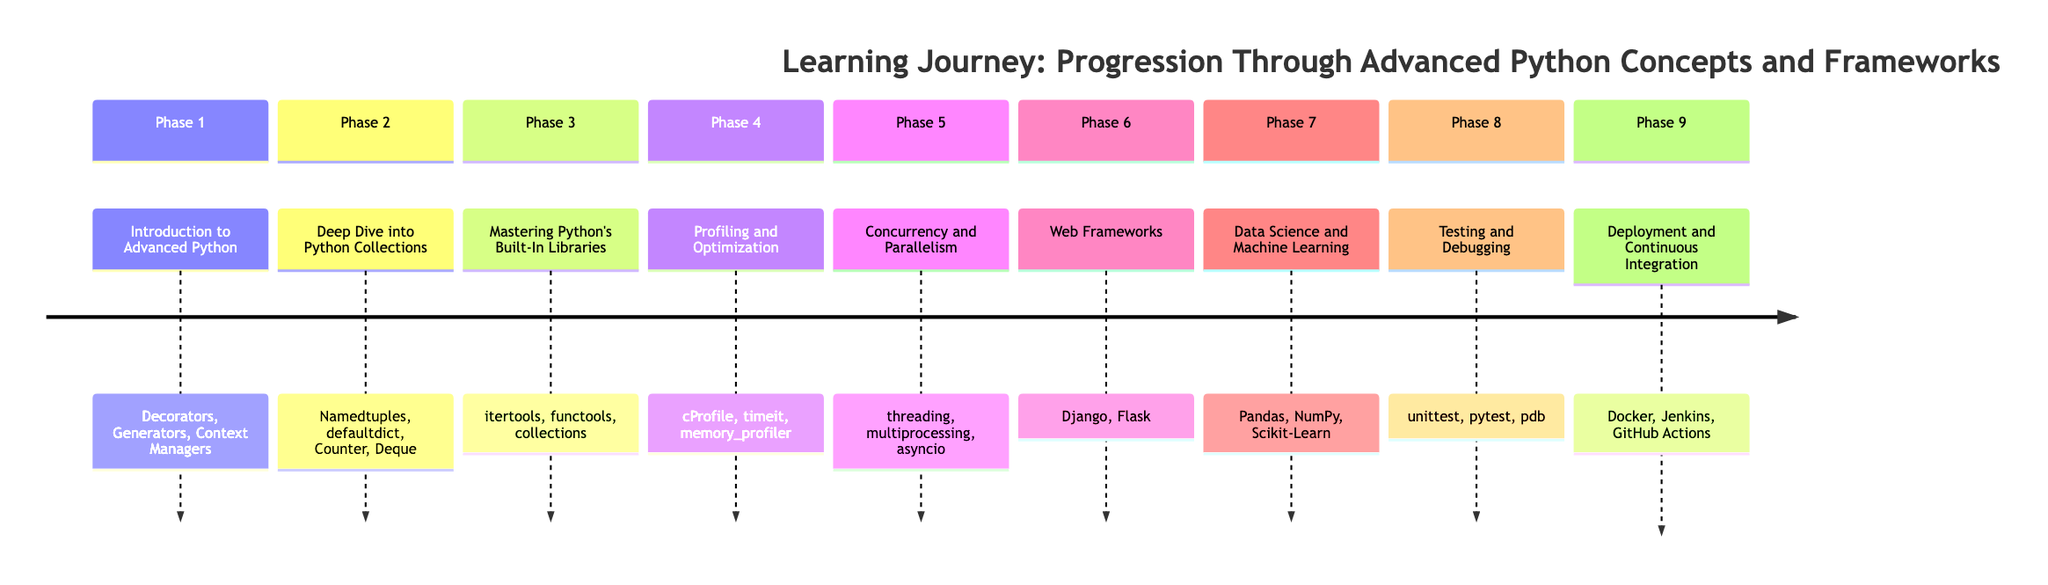What is the title of the timeline? The title is explicitly mentioned at the top of the timeline diagram, which reflects the overall theme of the learning journey.
Answer: Learning Journey: Progression Through Advanced Python Concepts and Frameworks How many phases are there in the learning journey? By counting the sections labeled "Phase 1" through "Phase 9" in the diagram, we can determine the total number of phases present.
Answer: 9 What topic is covered in Phase 4? Each phase in the timeline describes a specific focus, and Phase 4 clearly states its topic, which is part of the description for that phase.
Answer: Profiling and Optimization Which framework is mentioned in Phase 6? The diagram specifies a set of topics for each phase, and Phase 6 lists one or more frameworks, making it straightforward to identify any particular framework mentioned.
Answer: Django What are the two main topics in Phase 5? Phase 5 lists three topics as part of its description, among which are two specific terms that represent the main areas of focus in this phase, which can be identified by reading the phase's topic list.
Answer: threading, multiprocessing Which phase deals with Testing and Debugging? The section organization in the diagram makes it easy to locate the relevant phase by reading the titles of the sections and identifying the one focused on testing and debugging.
Answer: Phase 8 What tools are included in Phase 9 for Continuous Integration? The diagram provides a concise list of tools under Phase 9, requiring a careful reading of the mentioned tools to answer this question accurately.
Answer: Docker, Jenkins, GitHub Actions Which phase comes directly before Data Science and Machine Learning? To answer this question, one must identify the phase directly preceding Phase 7 by counting backward in the chronological order represented in the timeline.
Answer: Phase 6 What is the primary focus of Phase 2? The focus of each phase is outlined in the description, and identifying the central theme involves reading the summary provided for Phase 2 carefully.
Answer: Deep Dive into Python Collections 